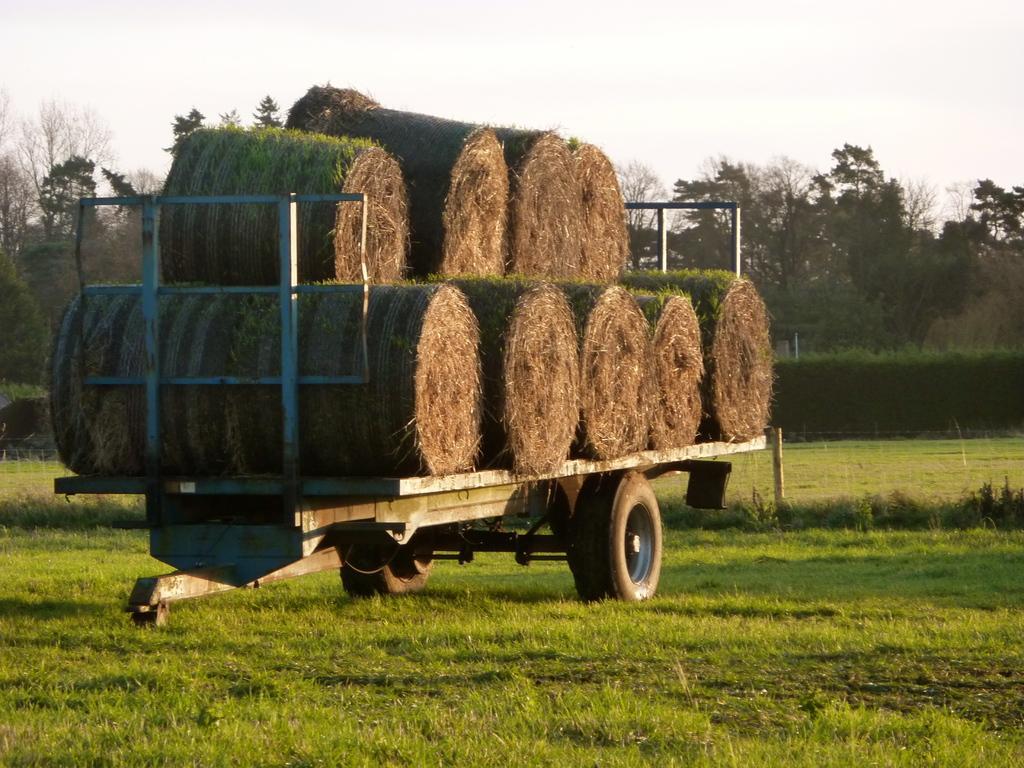In one or two sentences, can you explain what this image depicts? In the image we can see a vehicle, on the vehicle there are Hay. There is a grass, tree, pole and a sky. 